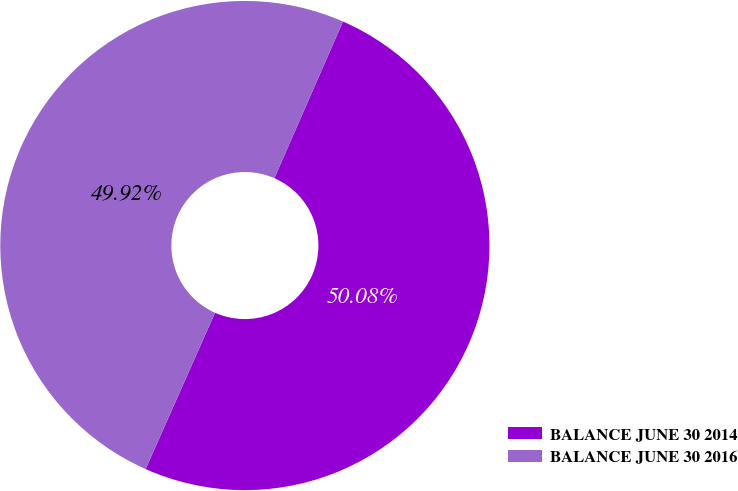Convert chart. <chart><loc_0><loc_0><loc_500><loc_500><pie_chart><fcel>BALANCE JUNE 30 2014<fcel>BALANCE JUNE 30 2016<nl><fcel>50.08%<fcel>49.92%<nl></chart> 